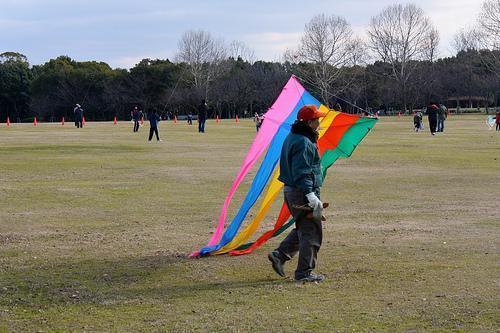How many people are there?
Give a very brief answer. 1. 